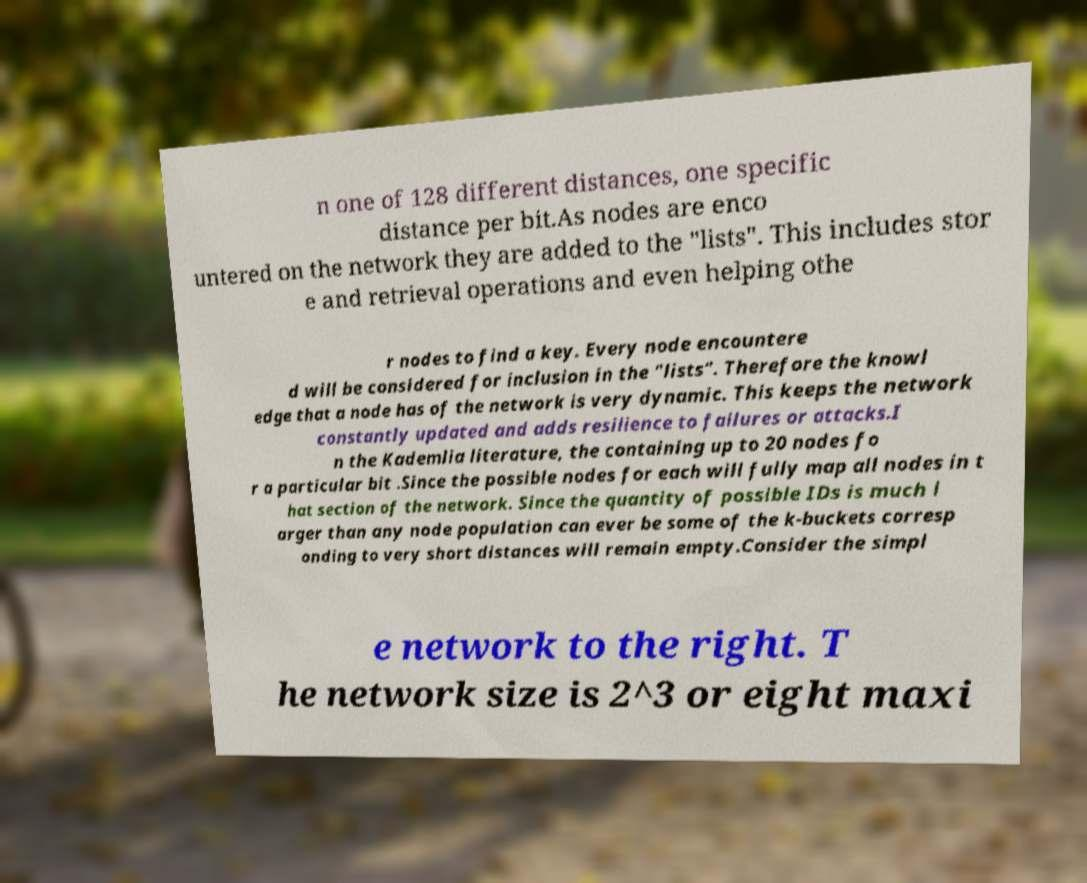Please read and relay the text visible in this image. What does it say? n one of 128 different distances, one specific distance per bit.As nodes are enco untered on the network they are added to the "lists". This includes stor e and retrieval operations and even helping othe r nodes to find a key. Every node encountere d will be considered for inclusion in the "lists". Therefore the knowl edge that a node has of the network is very dynamic. This keeps the network constantly updated and adds resilience to failures or attacks.I n the Kademlia literature, the containing up to 20 nodes fo r a particular bit .Since the possible nodes for each will fully map all nodes in t hat section of the network. Since the quantity of possible IDs is much l arger than any node population can ever be some of the k-buckets corresp onding to very short distances will remain empty.Consider the simpl e network to the right. T he network size is 2^3 or eight maxi 